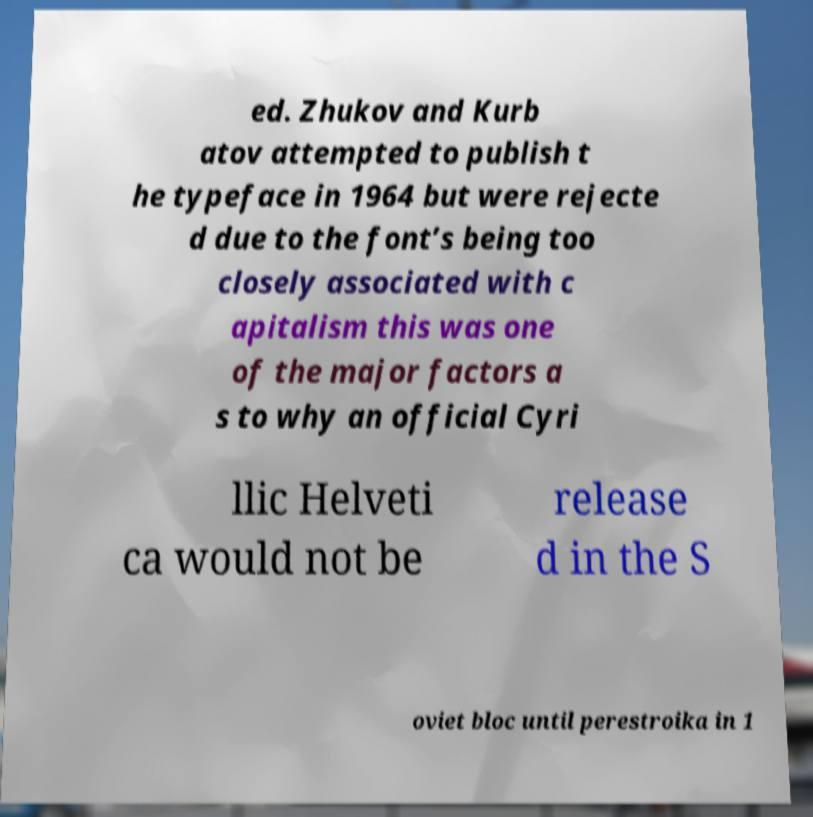Could you assist in decoding the text presented in this image and type it out clearly? ed. Zhukov and Kurb atov attempted to publish t he typeface in 1964 but were rejecte d due to the font’s being too closely associated with c apitalism this was one of the major factors a s to why an official Cyri llic Helveti ca would not be release d in the S oviet bloc until perestroika in 1 